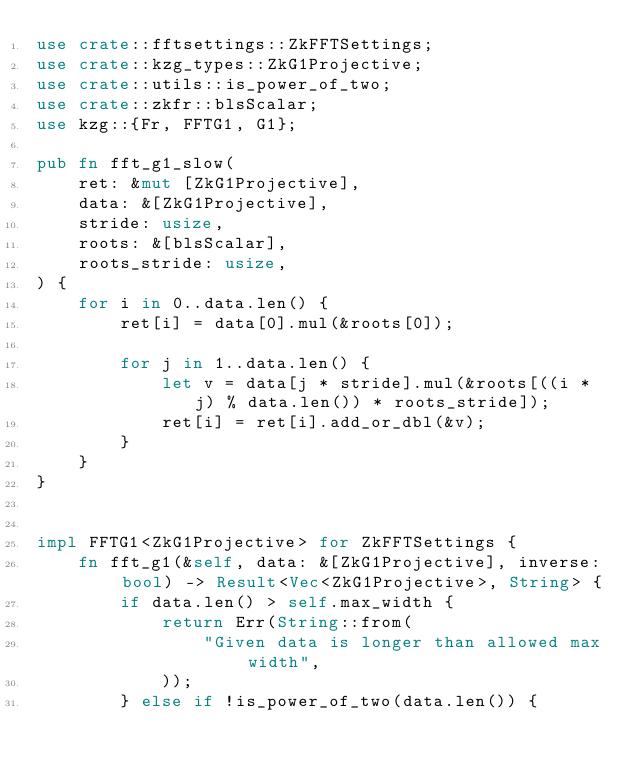Convert code to text. <code><loc_0><loc_0><loc_500><loc_500><_Rust_>use crate::fftsettings::ZkFFTSettings;
use crate::kzg_types::ZkG1Projective;
use crate::utils::is_power_of_two;
use crate::zkfr::blsScalar;
use kzg::{Fr, FFTG1, G1};

pub fn fft_g1_slow(
    ret: &mut [ZkG1Projective],
    data: &[ZkG1Projective],
    stride: usize,
    roots: &[blsScalar],
    roots_stride: usize,
) {
    for i in 0..data.len() {
        ret[i] = data[0].mul(&roots[0]);

        for j in 1..data.len() {
            let v = data[j * stride].mul(&roots[((i * j) % data.len()) * roots_stride]);
            ret[i] = ret[i].add_or_dbl(&v);
        }
    }
}


impl FFTG1<ZkG1Projective> for ZkFFTSettings {
    fn fft_g1(&self, data: &[ZkG1Projective], inverse: bool) -> Result<Vec<ZkG1Projective>, String> {
        if data.len() > self.max_width {
            return Err(String::from(
                "Given data is longer than allowed max width",
            ));
        } else if !is_power_of_two(data.len()) {</code> 